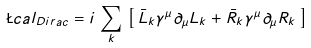Convert formula to latex. <formula><loc_0><loc_0><loc_500><loc_500>\L c a l _ { D i r a c } = i \, \sum _ { k } \, \left [ \, \bar { L } _ { k } \gamma ^ { \mu } { \partial } _ { \mu } L _ { k } + \bar { R } _ { k } \gamma ^ { \mu } \partial _ { \mu } R _ { k } \, \right ]</formula> 